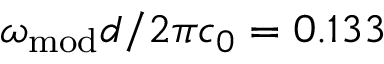<formula> <loc_0><loc_0><loc_500><loc_500>\omega _ { m o d } d / 2 \pi c _ { 0 } = 0 . 1 3 3</formula> 